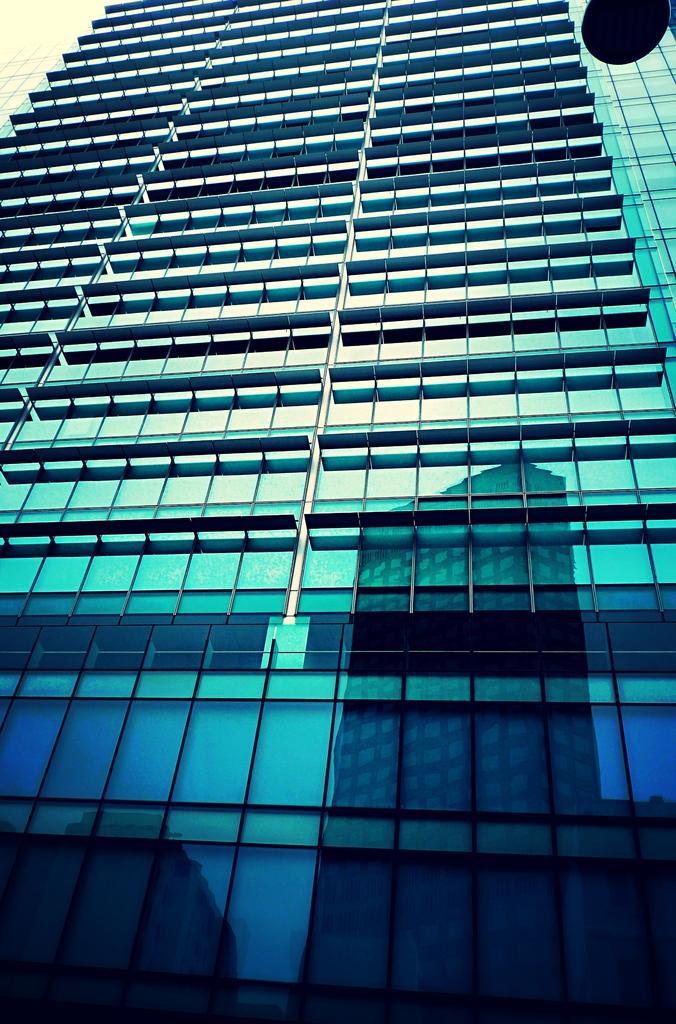In one or two sentences, can you explain what this image depicts? In this picture we can see a building. At the bottom of the image we can see the reflection of the buildings. 